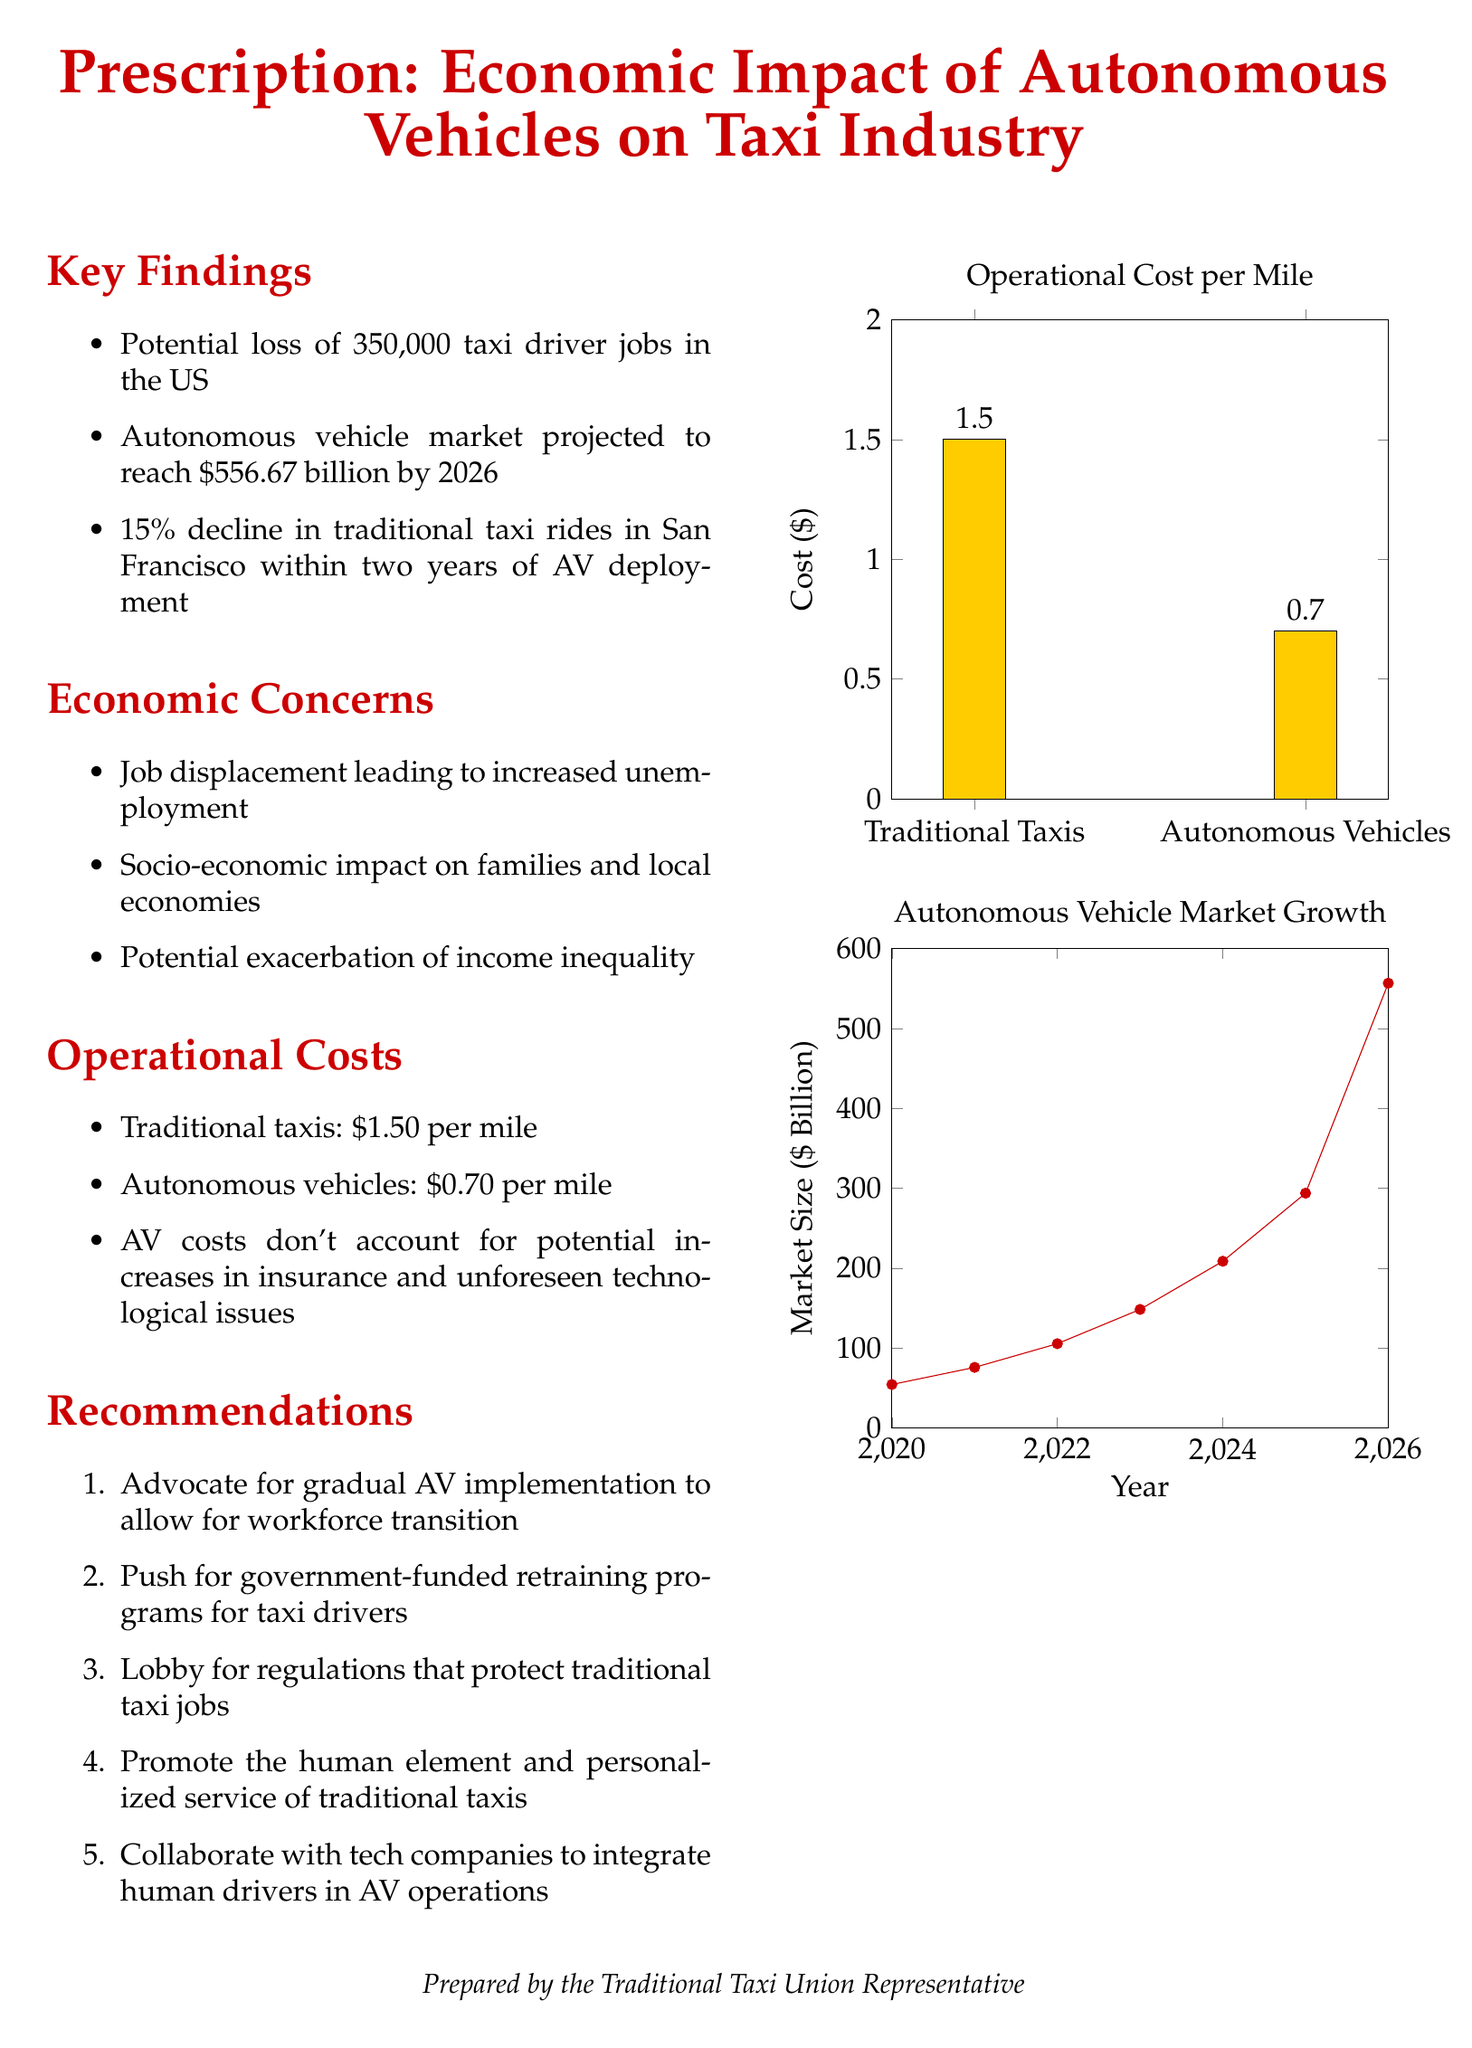What is the projected market size of autonomous vehicles by 2026? This information can be found in the key findings section, which states that the autonomous vehicle market is expected to reach $556.67 billion by 2026.
Answer: $556.67 billion How many taxi driver jobs are estimated to be lost in the US? The key findings section includes this estimate, stating that there is a potential loss of 350,000 taxi driver jobs in the US.
Answer: 350,000 What is the operational cost per mile for traditional taxis? The operational costs section specifies the cost, which is listed as $1.50 per mile for traditional taxis.
Answer: $1.50 per mile What is the percentage decline in traditional taxi rides in San Francisco after AV deployment? The key findings note this decline, indicating a 15% drop in traditional taxi rides within two years of autonomous vehicle deployment in San Francisco.
Answer: 15% What recommendation advocates for government-funded retraining programs for taxi drivers? The recommendations section includes this suggestion as the second point, which indicates support for retraining programs for displaced workers.
Answer: Advocate for gradual AV implementation to allow for workforce transition What year is the starting point for the autonomous vehicle market growth chart? The chart's x-axis begins at the year 2020, which marks the start of the market size data presented.
Answer: 2020 How much do autonomous vehicles cost per mile? The operational costs section details that the cost for autonomous vehicles is $0.70 per mile.
Answer: $0.70 per mile What socio-economic concern is mentioned in relation to autonomous vehicles? The economic concerns section outlines multiple issues, including the potential exacerbation of income inequality as a key concern.
Answer: Exacerbation of income inequality What does the document suggest about the human element in traditional taxis? The recommendations encompass promoting the human element and personalized service of traditional taxis as a vital aspect worth keeping.
Answer: Promote the human element and personalized service of traditional taxis 